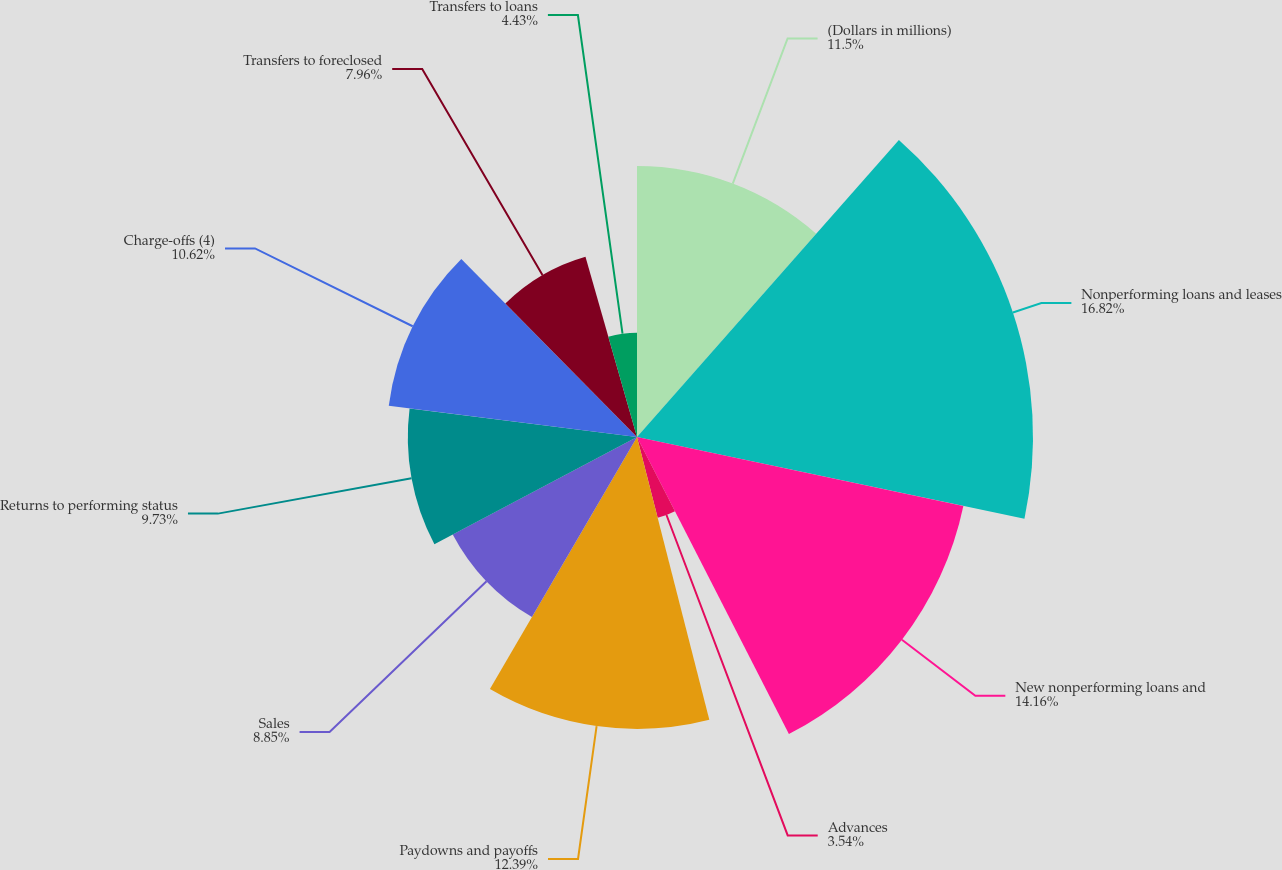Convert chart to OTSL. <chart><loc_0><loc_0><loc_500><loc_500><pie_chart><fcel>(Dollars in millions)<fcel>Nonperforming loans and leases<fcel>New nonperforming loans and<fcel>Advances<fcel>Paydowns and payoffs<fcel>Sales<fcel>Returns to performing status<fcel>Charge-offs (4)<fcel>Transfers to foreclosed<fcel>Transfers to loans<nl><fcel>11.5%<fcel>16.81%<fcel>14.16%<fcel>3.54%<fcel>12.39%<fcel>8.85%<fcel>9.73%<fcel>10.62%<fcel>7.96%<fcel>4.43%<nl></chart> 